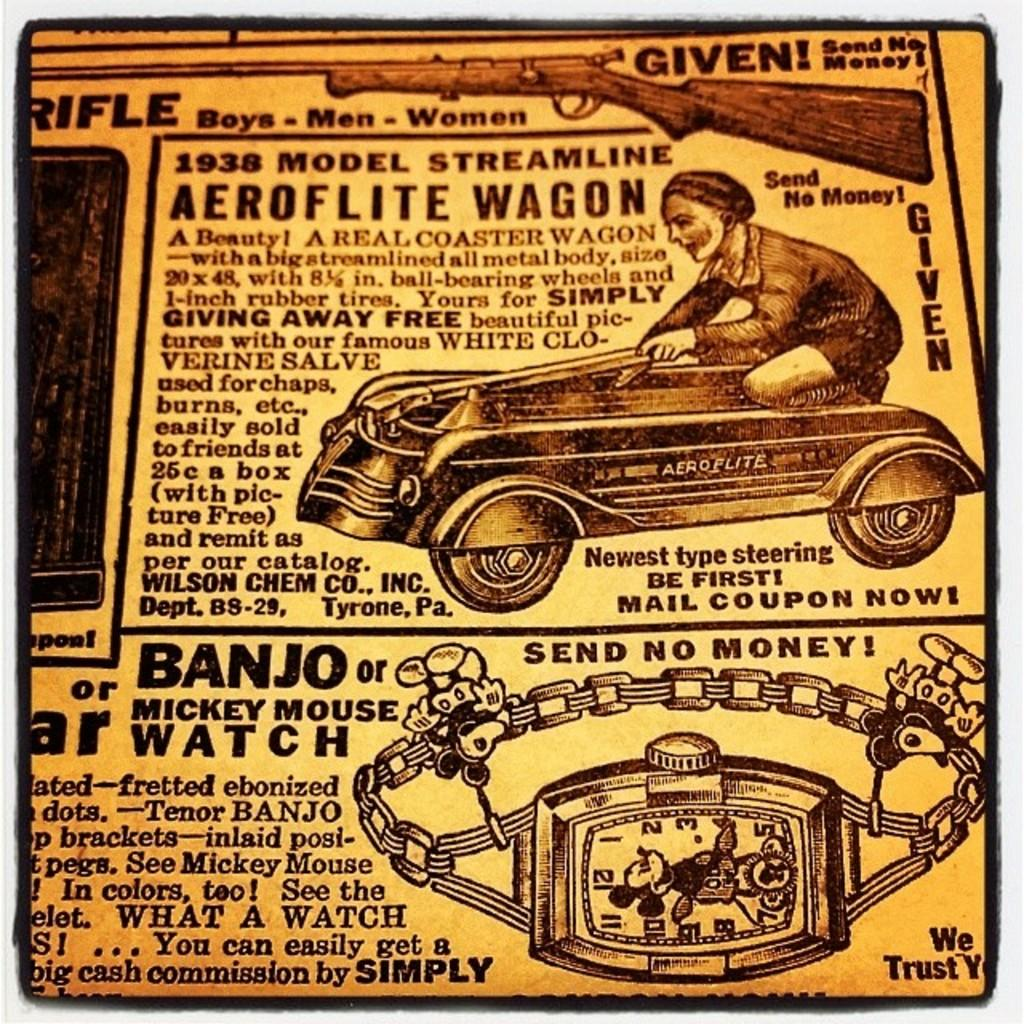What color is the prominent object in the image? There is a yellow object in the image. What is written on the yellow object? Something is written on the yellow object. Can you describe the depictions in the image? There is a depiction of a person, a watch, and a gun in the image. What religious symbol can be seen in the image? There is no religious symbol present in the image. How does the person depicted in the image move around? The person depicted in the image is a static image and does not move. 